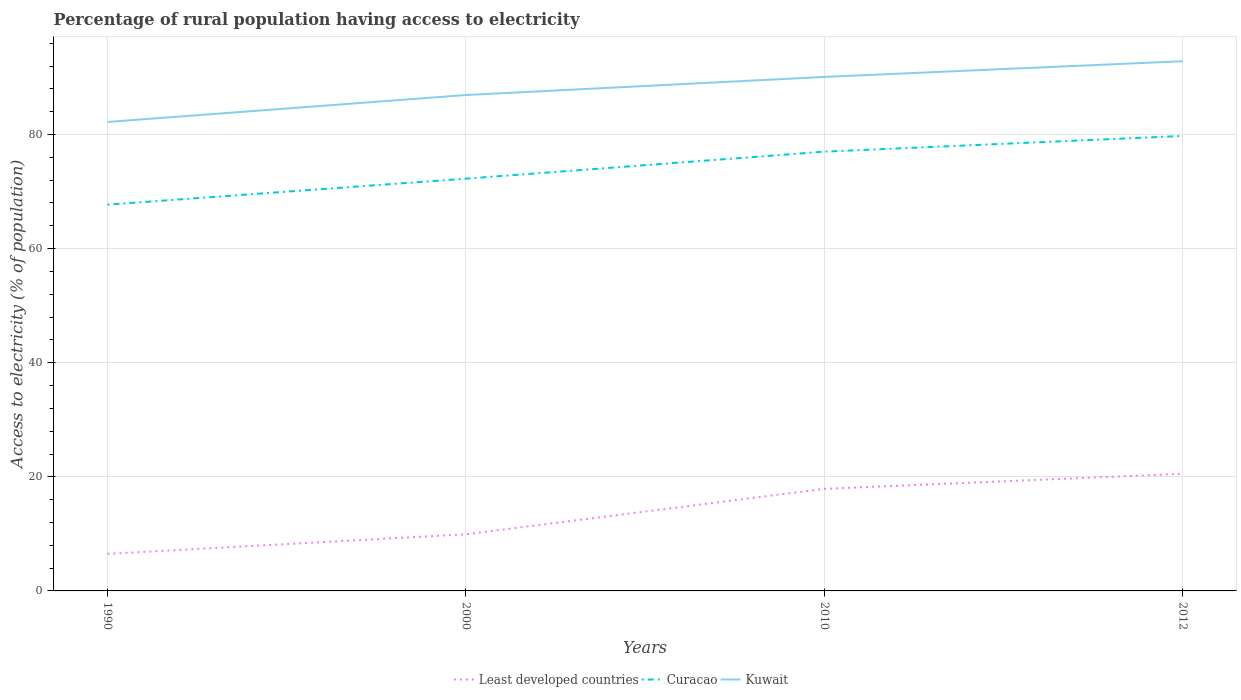Is the number of lines equal to the number of legend labels?
Offer a terse response. Yes. Across all years, what is the maximum percentage of rural population having access to electricity in Least developed countries?
Ensure brevity in your answer.  6.5. In which year was the percentage of rural population having access to electricity in Curacao maximum?
Provide a short and direct response. 1990. What is the total percentage of rural population having access to electricity in Curacao in the graph?
Offer a terse response. -9.29. What is the difference between the highest and the second highest percentage of rural population having access to electricity in Kuwait?
Offer a very short reply. 10.65. What is the difference between the highest and the lowest percentage of rural population having access to electricity in Least developed countries?
Give a very brief answer. 2. What is the difference between two consecutive major ticks on the Y-axis?
Provide a succinct answer. 20. Does the graph contain any zero values?
Provide a short and direct response. No. Does the graph contain grids?
Provide a short and direct response. Yes. What is the title of the graph?
Your answer should be compact. Percentage of rural population having access to electricity. What is the label or title of the X-axis?
Offer a very short reply. Years. What is the label or title of the Y-axis?
Provide a short and direct response. Access to electricity (% of population). What is the Access to electricity (% of population) of Least developed countries in 1990?
Your answer should be very brief. 6.5. What is the Access to electricity (% of population) of Curacao in 1990?
Your answer should be compact. 67.71. What is the Access to electricity (% of population) of Kuwait in 1990?
Provide a short and direct response. 82.2. What is the Access to electricity (% of population) in Least developed countries in 2000?
Provide a short and direct response. 9.93. What is the Access to electricity (% of population) in Curacao in 2000?
Ensure brevity in your answer.  72.27. What is the Access to electricity (% of population) of Kuwait in 2000?
Your answer should be compact. 86.93. What is the Access to electricity (% of population) of Least developed countries in 2010?
Give a very brief answer. 17.89. What is the Access to electricity (% of population) of Kuwait in 2010?
Offer a terse response. 90.1. What is the Access to electricity (% of population) in Least developed countries in 2012?
Your answer should be very brief. 20.54. What is the Access to electricity (% of population) of Curacao in 2012?
Your answer should be compact. 79.75. What is the Access to electricity (% of population) in Kuwait in 2012?
Your answer should be very brief. 92.85. Across all years, what is the maximum Access to electricity (% of population) of Least developed countries?
Your response must be concise. 20.54. Across all years, what is the maximum Access to electricity (% of population) of Curacao?
Give a very brief answer. 79.75. Across all years, what is the maximum Access to electricity (% of population) of Kuwait?
Offer a terse response. 92.85. Across all years, what is the minimum Access to electricity (% of population) of Least developed countries?
Make the answer very short. 6.5. Across all years, what is the minimum Access to electricity (% of population) of Curacao?
Your answer should be compact. 67.71. Across all years, what is the minimum Access to electricity (% of population) in Kuwait?
Give a very brief answer. 82.2. What is the total Access to electricity (% of population) of Least developed countries in the graph?
Your answer should be very brief. 54.86. What is the total Access to electricity (% of population) of Curacao in the graph?
Offer a very short reply. 296.73. What is the total Access to electricity (% of population) in Kuwait in the graph?
Provide a short and direct response. 352.08. What is the difference between the Access to electricity (% of population) of Least developed countries in 1990 and that in 2000?
Ensure brevity in your answer.  -3.43. What is the difference between the Access to electricity (% of population) in Curacao in 1990 and that in 2000?
Your response must be concise. -4.55. What is the difference between the Access to electricity (% of population) in Kuwait in 1990 and that in 2000?
Provide a succinct answer. -4.72. What is the difference between the Access to electricity (% of population) of Least developed countries in 1990 and that in 2010?
Your response must be concise. -11.4. What is the difference between the Access to electricity (% of population) in Curacao in 1990 and that in 2010?
Give a very brief answer. -9.29. What is the difference between the Access to electricity (% of population) in Kuwait in 1990 and that in 2010?
Ensure brevity in your answer.  -7.9. What is the difference between the Access to electricity (% of population) in Least developed countries in 1990 and that in 2012?
Your answer should be compact. -14.04. What is the difference between the Access to electricity (% of population) of Curacao in 1990 and that in 2012?
Make the answer very short. -12.04. What is the difference between the Access to electricity (% of population) of Kuwait in 1990 and that in 2012?
Provide a short and direct response. -10.65. What is the difference between the Access to electricity (% of population) of Least developed countries in 2000 and that in 2010?
Your response must be concise. -7.96. What is the difference between the Access to electricity (% of population) in Curacao in 2000 and that in 2010?
Your answer should be compact. -4.74. What is the difference between the Access to electricity (% of population) in Kuwait in 2000 and that in 2010?
Make the answer very short. -3.17. What is the difference between the Access to electricity (% of population) of Least developed countries in 2000 and that in 2012?
Provide a succinct answer. -10.6. What is the difference between the Access to electricity (% of population) of Curacao in 2000 and that in 2012?
Ensure brevity in your answer.  -7.49. What is the difference between the Access to electricity (% of population) of Kuwait in 2000 and that in 2012?
Your answer should be compact. -5.93. What is the difference between the Access to electricity (% of population) of Least developed countries in 2010 and that in 2012?
Make the answer very short. -2.64. What is the difference between the Access to electricity (% of population) of Curacao in 2010 and that in 2012?
Give a very brief answer. -2.75. What is the difference between the Access to electricity (% of population) of Kuwait in 2010 and that in 2012?
Your answer should be very brief. -2.75. What is the difference between the Access to electricity (% of population) in Least developed countries in 1990 and the Access to electricity (% of population) in Curacao in 2000?
Offer a terse response. -65.77. What is the difference between the Access to electricity (% of population) of Least developed countries in 1990 and the Access to electricity (% of population) of Kuwait in 2000?
Offer a very short reply. -80.43. What is the difference between the Access to electricity (% of population) of Curacao in 1990 and the Access to electricity (% of population) of Kuwait in 2000?
Give a very brief answer. -19.21. What is the difference between the Access to electricity (% of population) of Least developed countries in 1990 and the Access to electricity (% of population) of Curacao in 2010?
Give a very brief answer. -70.5. What is the difference between the Access to electricity (% of population) in Least developed countries in 1990 and the Access to electricity (% of population) in Kuwait in 2010?
Ensure brevity in your answer.  -83.6. What is the difference between the Access to electricity (% of population) of Curacao in 1990 and the Access to electricity (% of population) of Kuwait in 2010?
Your answer should be compact. -22.39. What is the difference between the Access to electricity (% of population) of Least developed countries in 1990 and the Access to electricity (% of population) of Curacao in 2012?
Provide a succinct answer. -73.26. What is the difference between the Access to electricity (% of population) of Least developed countries in 1990 and the Access to electricity (% of population) of Kuwait in 2012?
Your answer should be compact. -86.36. What is the difference between the Access to electricity (% of population) in Curacao in 1990 and the Access to electricity (% of population) in Kuwait in 2012?
Offer a very short reply. -25.14. What is the difference between the Access to electricity (% of population) in Least developed countries in 2000 and the Access to electricity (% of population) in Curacao in 2010?
Your answer should be very brief. -67.07. What is the difference between the Access to electricity (% of population) in Least developed countries in 2000 and the Access to electricity (% of population) in Kuwait in 2010?
Ensure brevity in your answer.  -80.17. What is the difference between the Access to electricity (% of population) of Curacao in 2000 and the Access to electricity (% of population) of Kuwait in 2010?
Provide a succinct answer. -17.84. What is the difference between the Access to electricity (% of population) in Least developed countries in 2000 and the Access to electricity (% of population) in Curacao in 2012?
Offer a terse response. -69.82. What is the difference between the Access to electricity (% of population) in Least developed countries in 2000 and the Access to electricity (% of population) in Kuwait in 2012?
Give a very brief answer. -82.92. What is the difference between the Access to electricity (% of population) in Curacao in 2000 and the Access to electricity (% of population) in Kuwait in 2012?
Give a very brief answer. -20.59. What is the difference between the Access to electricity (% of population) of Least developed countries in 2010 and the Access to electricity (% of population) of Curacao in 2012?
Offer a very short reply. -61.86. What is the difference between the Access to electricity (% of population) of Least developed countries in 2010 and the Access to electricity (% of population) of Kuwait in 2012?
Provide a short and direct response. -74.96. What is the difference between the Access to electricity (% of population) in Curacao in 2010 and the Access to electricity (% of population) in Kuwait in 2012?
Offer a terse response. -15.85. What is the average Access to electricity (% of population) in Least developed countries per year?
Offer a very short reply. 13.71. What is the average Access to electricity (% of population) in Curacao per year?
Make the answer very short. 74.18. What is the average Access to electricity (% of population) in Kuwait per year?
Make the answer very short. 88.02. In the year 1990, what is the difference between the Access to electricity (% of population) of Least developed countries and Access to electricity (% of population) of Curacao?
Your response must be concise. -61.21. In the year 1990, what is the difference between the Access to electricity (% of population) of Least developed countries and Access to electricity (% of population) of Kuwait?
Give a very brief answer. -75.7. In the year 1990, what is the difference between the Access to electricity (% of population) of Curacao and Access to electricity (% of population) of Kuwait?
Provide a succinct answer. -14.49. In the year 2000, what is the difference between the Access to electricity (% of population) in Least developed countries and Access to electricity (% of population) in Curacao?
Your response must be concise. -62.33. In the year 2000, what is the difference between the Access to electricity (% of population) of Least developed countries and Access to electricity (% of population) of Kuwait?
Keep it short and to the point. -76.99. In the year 2000, what is the difference between the Access to electricity (% of population) in Curacao and Access to electricity (% of population) in Kuwait?
Provide a succinct answer. -14.66. In the year 2010, what is the difference between the Access to electricity (% of population) in Least developed countries and Access to electricity (% of population) in Curacao?
Your answer should be compact. -59.11. In the year 2010, what is the difference between the Access to electricity (% of population) in Least developed countries and Access to electricity (% of population) in Kuwait?
Your answer should be compact. -72.21. In the year 2010, what is the difference between the Access to electricity (% of population) of Curacao and Access to electricity (% of population) of Kuwait?
Give a very brief answer. -13.1. In the year 2012, what is the difference between the Access to electricity (% of population) in Least developed countries and Access to electricity (% of population) in Curacao?
Your answer should be compact. -59.22. In the year 2012, what is the difference between the Access to electricity (% of population) of Least developed countries and Access to electricity (% of population) of Kuwait?
Your answer should be very brief. -72.32. What is the ratio of the Access to electricity (% of population) of Least developed countries in 1990 to that in 2000?
Provide a succinct answer. 0.65. What is the ratio of the Access to electricity (% of population) in Curacao in 1990 to that in 2000?
Keep it short and to the point. 0.94. What is the ratio of the Access to electricity (% of population) of Kuwait in 1990 to that in 2000?
Provide a short and direct response. 0.95. What is the ratio of the Access to electricity (% of population) in Least developed countries in 1990 to that in 2010?
Your answer should be very brief. 0.36. What is the ratio of the Access to electricity (% of population) of Curacao in 1990 to that in 2010?
Provide a short and direct response. 0.88. What is the ratio of the Access to electricity (% of population) in Kuwait in 1990 to that in 2010?
Provide a succinct answer. 0.91. What is the ratio of the Access to electricity (% of population) in Least developed countries in 1990 to that in 2012?
Offer a terse response. 0.32. What is the ratio of the Access to electricity (% of population) of Curacao in 1990 to that in 2012?
Ensure brevity in your answer.  0.85. What is the ratio of the Access to electricity (% of population) of Kuwait in 1990 to that in 2012?
Your answer should be compact. 0.89. What is the ratio of the Access to electricity (% of population) of Least developed countries in 2000 to that in 2010?
Provide a succinct answer. 0.56. What is the ratio of the Access to electricity (% of population) in Curacao in 2000 to that in 2010?
Your answer should be very brief. 0.94. What is the ratio of the Access to electricity (% of population) of Kuwait in 2000 to that in 2010?
Provide a short and direct response. 0.96. What is the ratio of the Access to electricity (% of population) of Least developed countries in 2000 to that in 2012?
Your answer should be compact. 0.48. What is the ratio of the Access to electricity (% of population) in Curacao in 2000 to that in 2012?
Your response must be concise. 0.91. What is the ratio of the Access to electricity (% of population) in Kuwait in 2000 to that in 2012?
Ensure brevity in your answer.  0.94. What is the ratio of the Access to electricity (% of population) of Least developed countries in 2010 to that in 2012?
Your answer should be very brief. 0.87. What is the ratio of the Access to electricity (% of population) in Curacao in 2010 to that in 2012?
Your answer should be compact. 0.97. What is the ratio of the Access to electricity (% of population) in Kuwait in 2010 to that in 2012?
Provide a short and direct response. 0.97. What is the difference between the highest and the second highest Access to electricity (% of population) of Least developed countries?
Make the answer very short. 2.64. What is the difference between the highest and the second highest Access to electricity (% of population) of Curacao?
Your answer should be very brief. 2.75. What is the difference between the highest and the second highest Access to electricity (% of population) of Kuwait?
Offer a very short reply. 2.75. What is the difference between the highest and the lowest Access to electricity (% of population) in Least developed countries?
Ensure brevity in your answer.  14.04. What is the difference between the highest and the lowest Access to electricity (% of population) in Curacao?
Make the answer very short. 12.04. What is the difference between the highest and the lowest Access to electricity (% of population) in Kuwait?
Your answer should be compact. 10.65. 